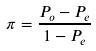Convert formula to latex. <formula><loc_0><loc_0><loc_500><loc_500>\pi = \frac { P _ { o } - P _ { e } } { 1 - P _ { e } }</formula> 